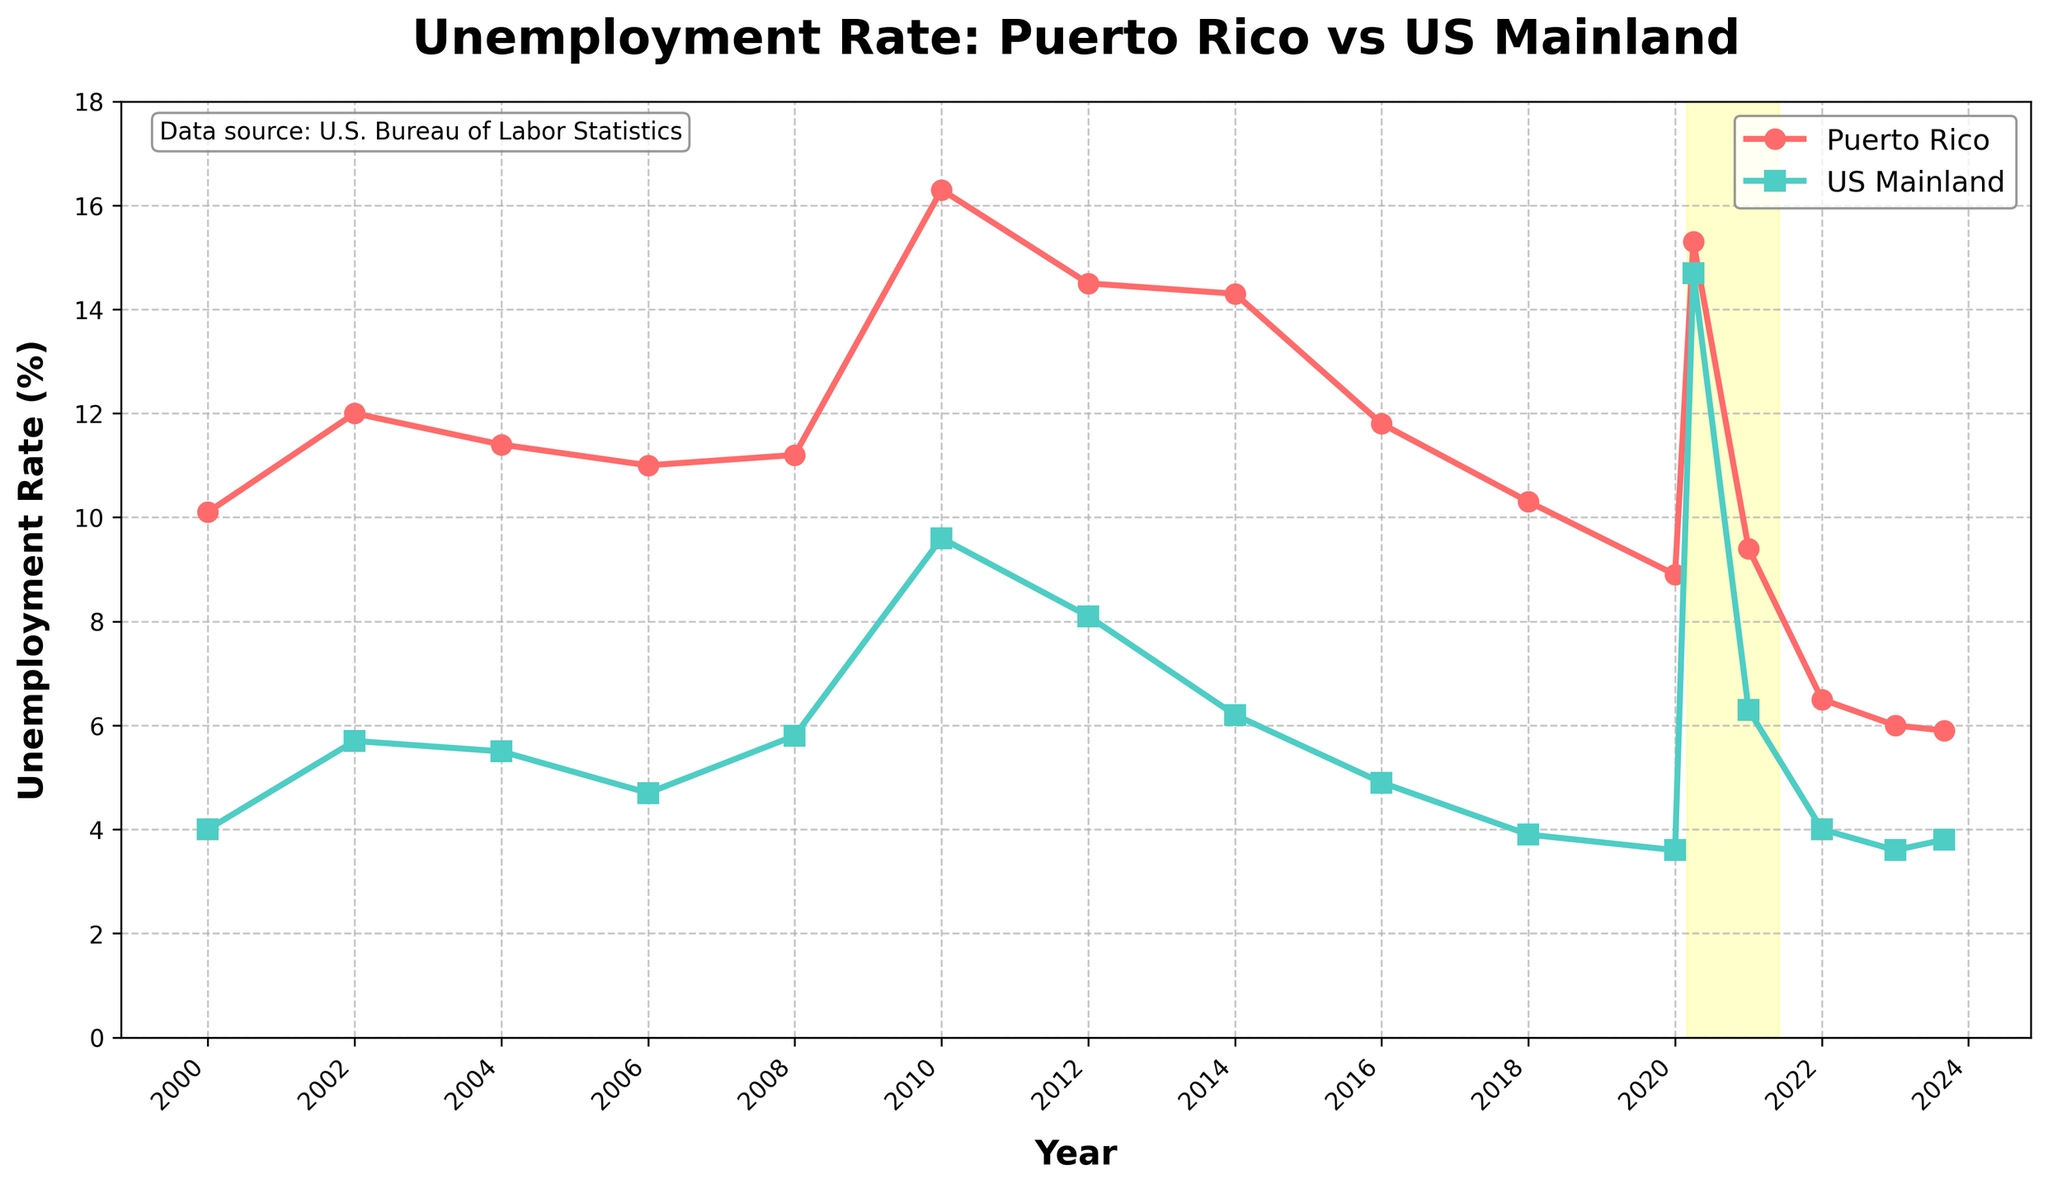Which year had the highest unemployment rate in Puerto Rico? Look for the peak point on the line representing Puerto Rico's unemployment rate. The highest point is at 2010 with a rate of 16.3%.
Answer: 2010 By how much did the unemployment rate in Puerto Rico decrease from 2010 to 2023? Identify the unemployment rates for Puerto Rico in 2010 and 2023. Subtract the latter from the former: 16.3% - 5.9% = 10.4%.
Answer: 10.4% In which year was the unemployment rate in the US mainland highest, and what was the rate? Examine the peaks in the line representing the US mainland’s unemployment rate. The highest point is in April 2020 with a rate of 14.7%.
Answer: April 2020, 14.7% How do the unemployment rates of Puerto Rico and the US mainland compare in January 2020? Compare the values on both lines for January 2020. Puerto Rico’s rate is 8.9% and the US mainland’s rate is 3.6%. Puerto Rico’s rate is higher.
Answer: Puerto Rico’s rate is higher What is the difference in unemployment rate between Puerto Rico and the US mainland in April 2020? Locate the unemployment rates for both Puerto Rico and the US mainland in April 2020. The difference is 15.3% - 14.7% = 0.6%.
Answer: 0.6% During the COVID-19 period (highlighted in yellow), what trend do you observe in the unemployment rates of both regions? Observe the lines within the highlighted section. Both Puerto Rico and the US mainland show a significant spike in unemployment rates during this period.
Answer: Significant spike What was the unemployment rate trend in Puerto Rico from 2000 to 2006? Examine the line for Puerto Rico from 2000 to 2006. The trend shows an initial increase followed by a decline in the unemployment rate.
Answer: Increase then decline By how much did the unemployment rate in the US mainland change from 2010 to 2021? Compare the unemployment rates for the US mainland in 2010 and 2021. The change is 9.6% - 6.3% = 3.3%.
Answer: 3.3% Which region had a lower unemployment rate in 2014, and by how much? Compare the unemployment rates for Puerto Rico and the US mainland in 2014. The US mainland had a lower rate: 14.3% - 6.2% = 8.1%.
Answer: US mainland, 8.1% What visual difference do you notice between the markers for Puerto Rico and the US mainland? Observe the markers on the lines. Puerto Rico uses circle markers while the US mainland uses square markers.
Answer: Circle vs. square 